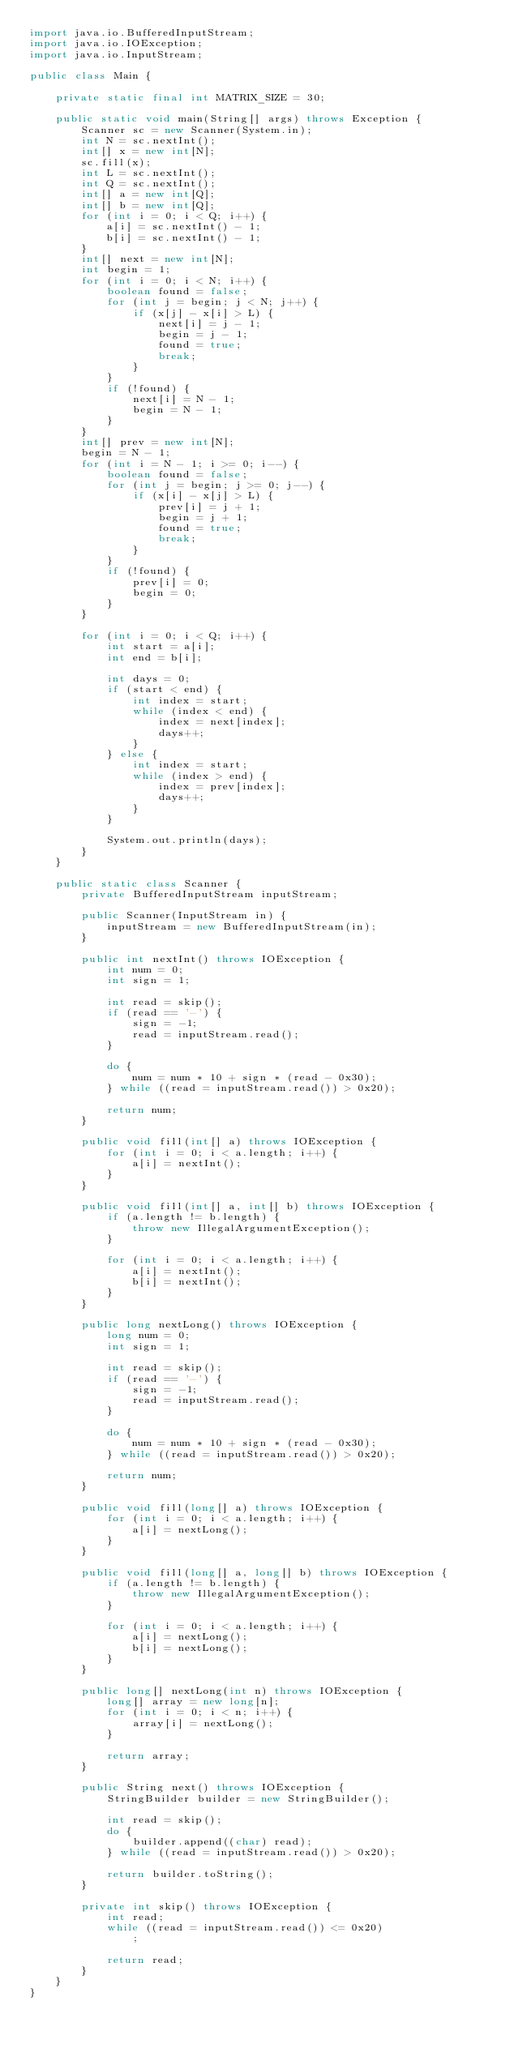<code> <loc_0><loc_0><loc_500><loc_500><_Java_>import java.io.BufferedInputStream;
import java.io.IOException;
import java.io.InputStream;

public class Main {

	private static final int MATRIX_SIZE = 30;

	public static void main(String[] args) throws Exception {
		Scanner sc = new Scanner(System.in);
		int N = sc.nextInt();
		int[] x = new int[N];
		sc.fill(x);
		int L = sc.nextInt();
		int Q = sc.nextInt();
		int[] a = new int[Q];
		int[] b = new int[Q];
		for (int i = 0; i < Q; i++) {
			a[i] = sc.nextInt() - 1;
			b[i] = sc.nextInt() - 1;
		}
		int[] next = new int[N];
		int begin = 1;
		for (int i = 0; i < N; i++) {
			boolean found = false;
			for (int j = begin; j < N; j++) {
				if (x[j] - x[i] > L) {
					next[i] = j - 1;
					begin = j - 1;
					found = true;
					break;
				}
			}
			if (!found) {
				next[i] = N - 1;
				begin = N - 1;
			}
		}
		int[] prev = new int[N];
		begin = N - 1;
		for (int i = N - 1; i >= 0; i--) {
			boolean found = false;
			for (int j = begin; j >= 0; j--) {
				if (x[i] - x[j] > L) {
					prev[i] = j + 1;
					begin = j + 1;
					found = true;
					break;
				}
			}
			if (!found) {
				prev[i] = 0;
				begin = 0;
			}
		}

		for (int i = 0; i < Q; i++) {
			int start = a[i];
			int end = b[i];

			int days = 0;
			if (start < end) {
				int index = start;
				while (index < end) {
					index = next[index];
					days++;
				}
			} else {
				int index = start;
				while (index > end) {
					index = prev[index];
					days++;
				}
			}

			System.out.println(days);
		}
	}

	public static class Scanner {
		private BufferedInputStream inputStream;

		public Scanner(InputStream in) {
			inputStream = new BufferedInputStream(in);
		}

		public int nextInt() throws IOException {
			int num = 0;
			int sign = 1;

			int read = skip();
			if (read == '-') {
				sign = -1;
				read = inputStream.read();
			}

			do {
				num = num * 10 + sign * (read - 0x30);
			} while ((read = inputStream.read()) > 0x20);

			return num;
		}

		public void fill(int[] a) throws IOException {
			for (int i = 0; i < a.length; i++) {
				a[i] = nextInt();
			}
		}

		public void fill(int[] a, int[] b) throws IOException {
			if (a.length != b.length) {
				throw new IllegalArgumentException();
			}

			for (int i = 0; i < a.length; i++) {
				a[i] = nextInt();
				b[i] = nextInt();
			}
		}

		public long nextLong() throws IOException {
			long num = 0;
			int sign = 1;

			int read = skip();
			if (read == '-') {
				sign = -1;
				read = inputStream.read();
			}

			do {
				num = num * 10 + sign * (read - 0x30);
			} while ((read = inputStream.read()) > 0x20);

			return num;
		}

		public void fill(long[] a) throws IOException {
			for (int i = 0; i < a.length; i++) {
				a[i] = nextLong();
			}
		}

		public void fill(long[] a, long[] b) throws IOException {
			if (a.length != b.length) {
				throw new IllegalArgumentException();
			}

			for (int i = 0; i < a.length; i++) {
				a[i] = nextLong();
				b[i] = nextLong();
			}
		}

		public long[] nextLong(int n) throws IOException {
			long[] array = new long[n];
			for (int i = 0; i < n; i++) {
				array[i] = nextLong();
			}

			return array;
		}

		public String next() throws IOException {
			StringBuilder builder = new StringBuilder();

			int read = skip();
			do {
				builder.append((char) read);
			} while ((read = inputStream.read()) > 0x20);

			return builder.toString();
		}

		private int skip() throws IOException {
			int read;
			while ((read = inputStream.read()) <= 0x20)
				;

			return read;
		}
	}
}
</code> 